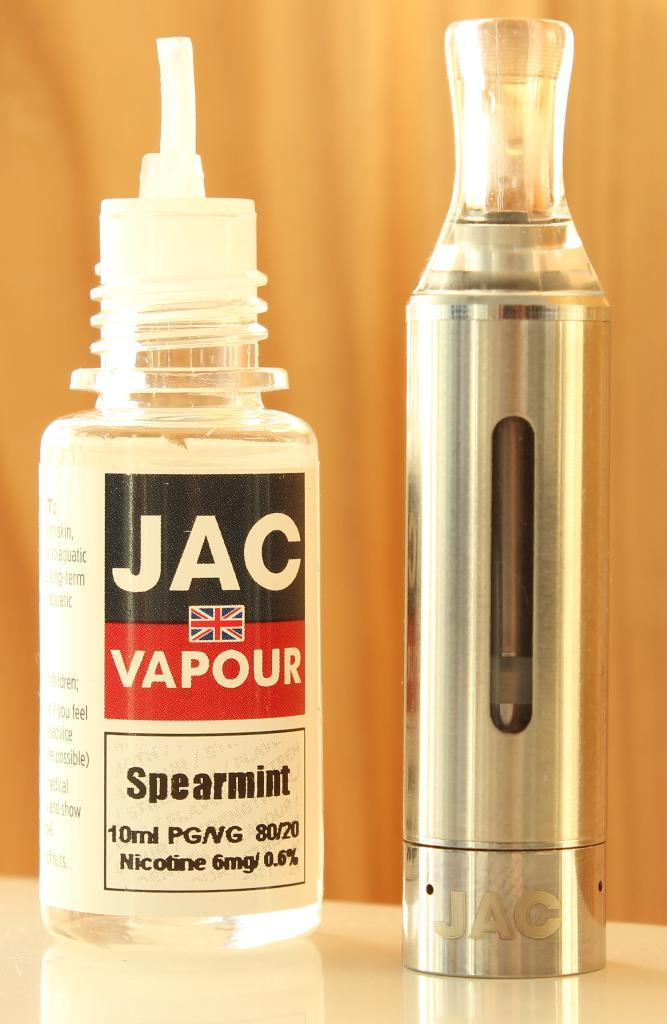<image>
Write a terse but informative summary of the picture. A bottle of JAC Vapor in spearmint flavor is next to a JAC vape pen. 